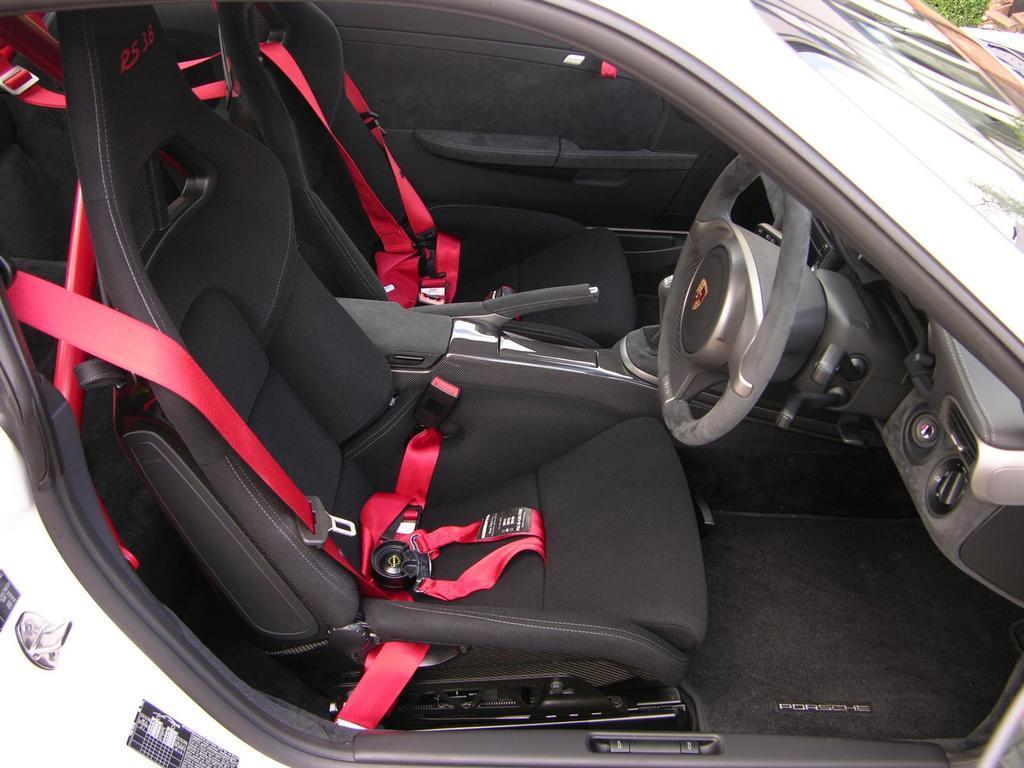Could you give a brief overview of what you see in this image? This image is an inside view of a car. 